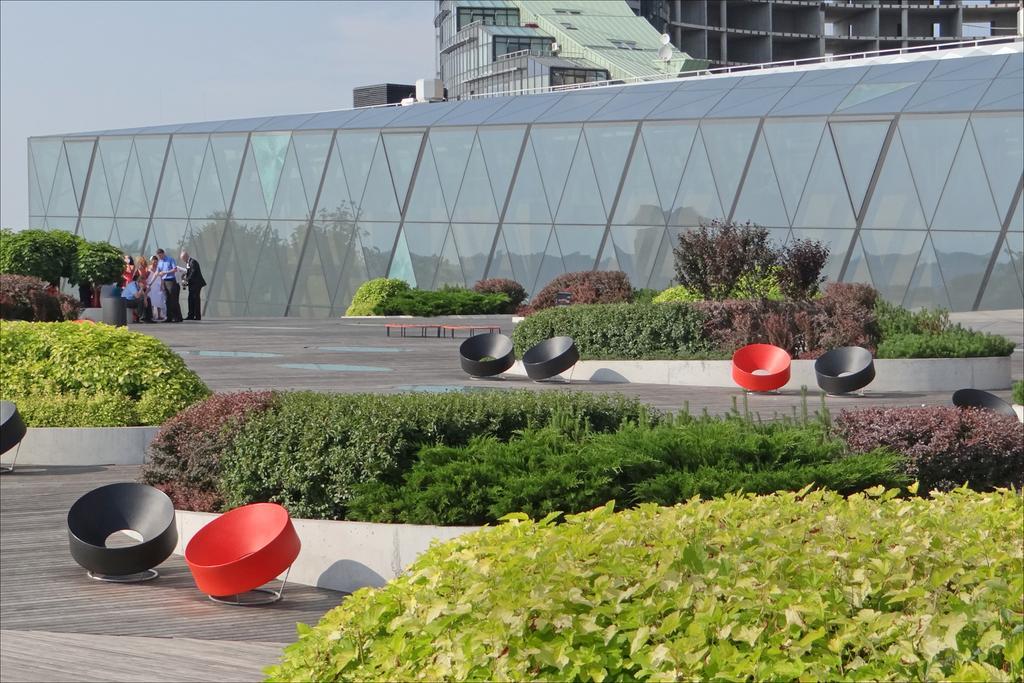Describe this image in one or two sentences. In this image we can see some plants and trees and there are some people on the left side of the image. We can see the buildings in the background and there are some objects which looks like chairs and at the top we can see the sky. 